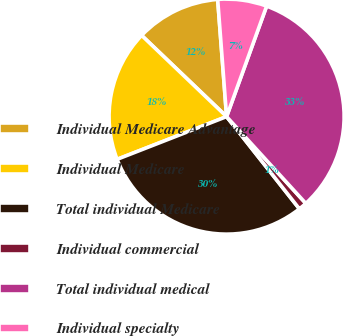Convert chart to OTSL. <chart><loc_0><loc_0><loc_500><loc_500><pie_chart><fcel>Individual Medicare Advantage<fcel>Individual Medicare<fcel>Total individual Medicare<fcel>Individual commercial<fcel>Total individual medical<fcel>Individual specialty<nl><fcel>11.65%<fcel>18.06%<fcel>29.71%<fcel>1.14%<fcel>32.69%<fcel>6.74%<nl></chart> 